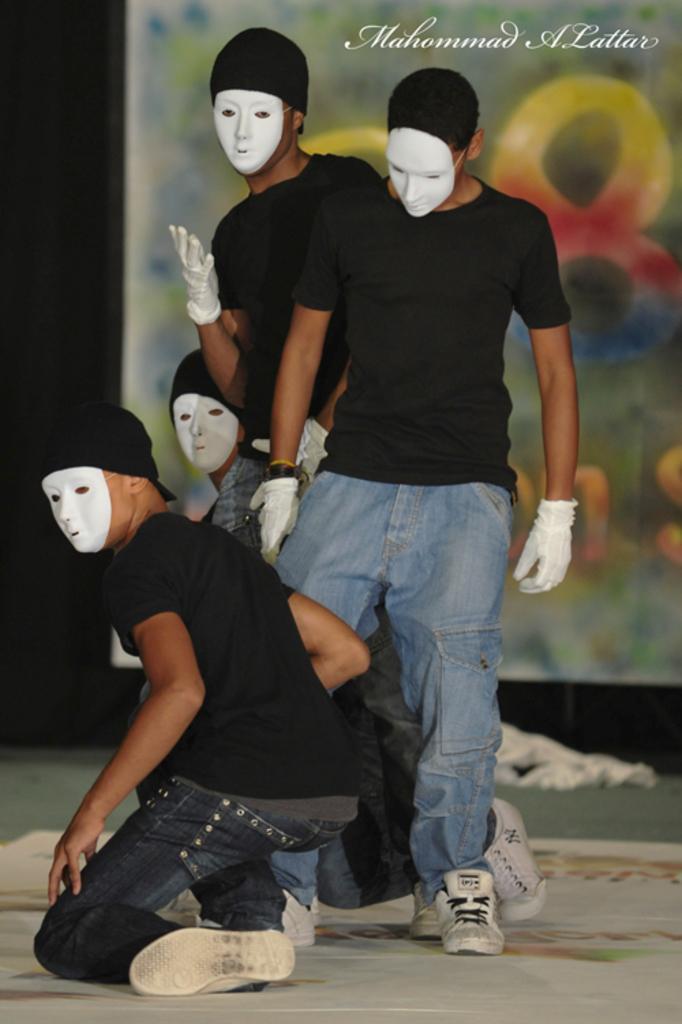Please provide a concise description of this image. Here I can see four men wearing t-shirts, jeans and masks to the faces. Two men are standing and another two men are sitting on the knees. It seems to be they are dancing on the floor. In the background there is a board. In the top right, I can see some text. 